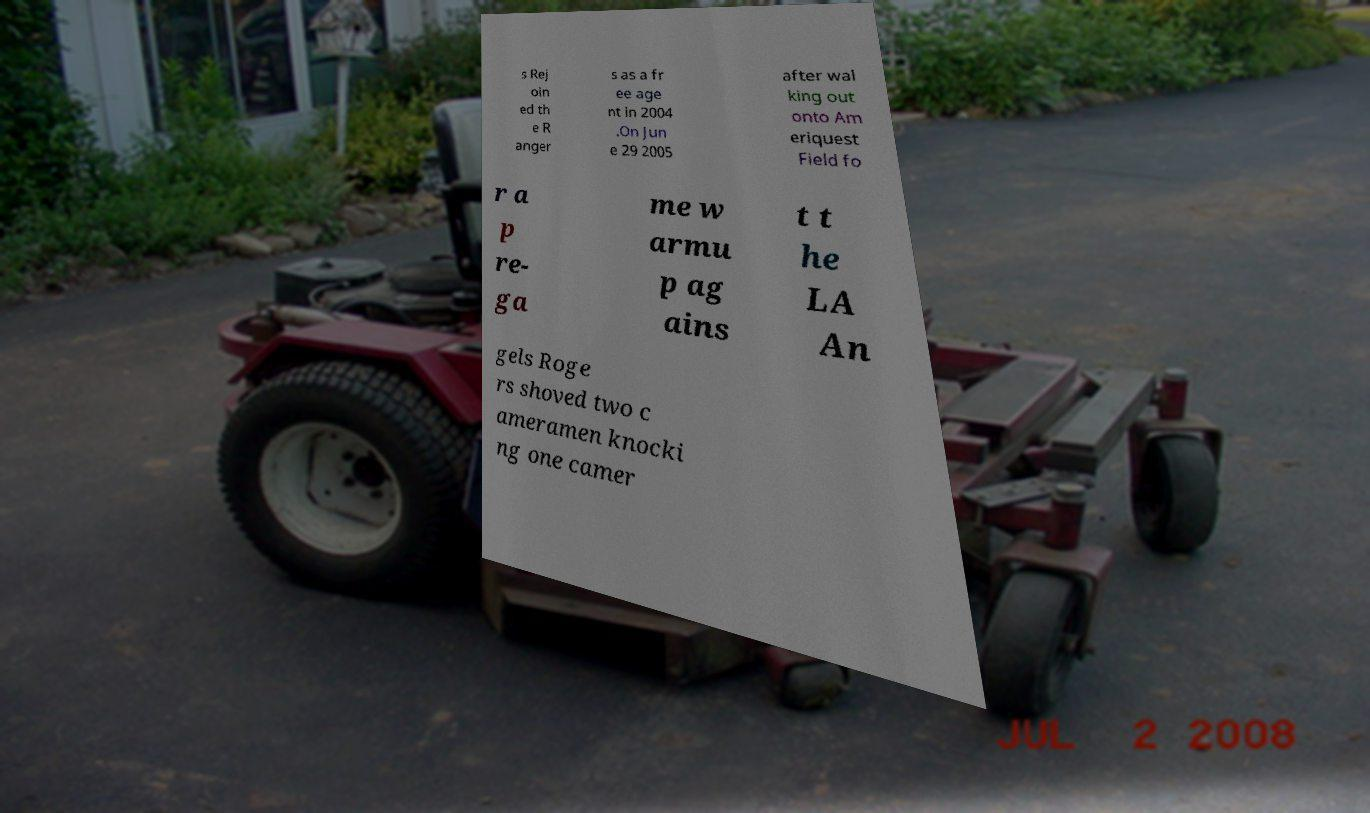Could you assist in decoding the text presented in this image and type it out clearly? s Rej oin ed th e R anger s as a fr ee age nt in 2004 .On Jun e 29 2005 after wal king out onto Am eriquest Field fo r a p re- ga me w armu p ag ains t t he LA An gels Roge rs shoved two c ameramen knocki ng one camer 